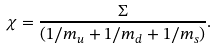Convert formula to latex. <formula><loc_0><loc_0><loc_500><loc_500>\chi = \frac { \Sigma } { \left ( 1 / m _ { u } + 1 / m _ { d } + 1 / m _ { s } \right ) } .</formula> 